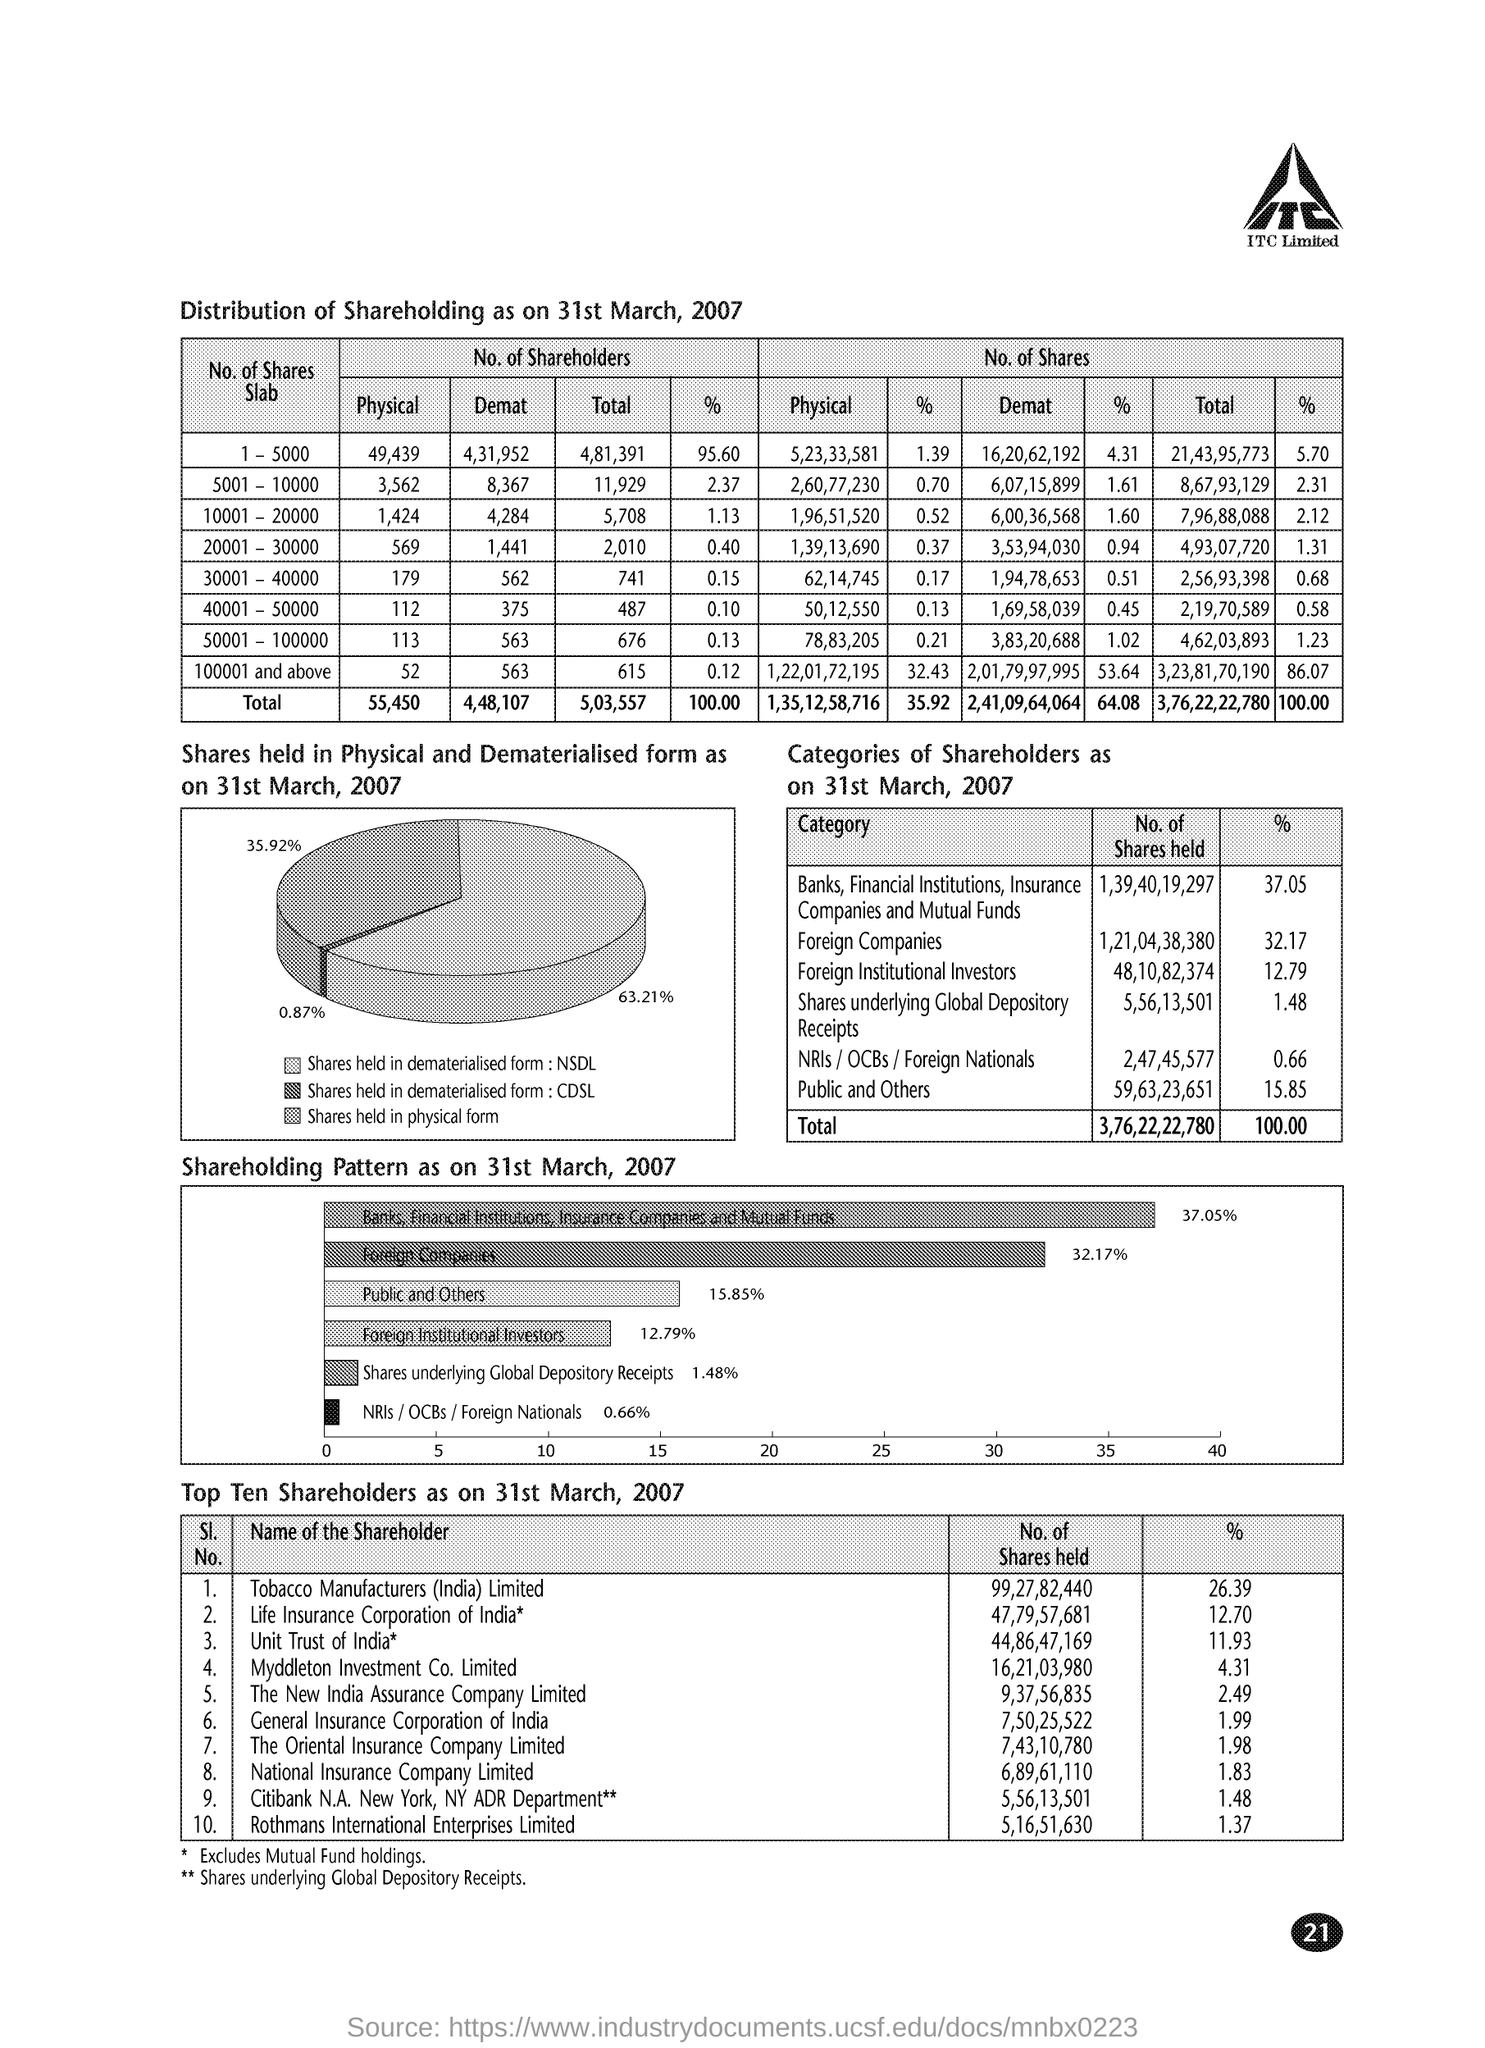Specify some key components in this picture. As of March 31, 2007, the number of shares held by Foreign Institutional Investors was 48,10,82,374. As of March 31, 2007, The Oriental Insurance Company Limited held approximately 1.98% of the total shares outstanding. The number of shares held by Tobacco Manufacturers (India) Limited as of March 31, 2007 was 99,27,82,440. The National Insurance Company Limited held 6,89,61,110 shares as of March 31, 2007. As of March 31, 2007, The New India Assurance Company Limited held approximately 2.49% of the company's shares. 